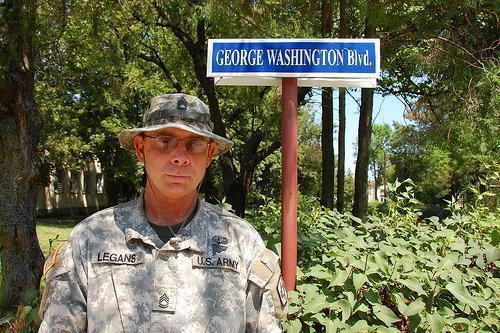How many people are in the picture?
Give a very brief answer. 1. 